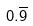<formula> <loc_0><loc_0><loc_500><loc_500>0 . \overline { 9 }</formula> 